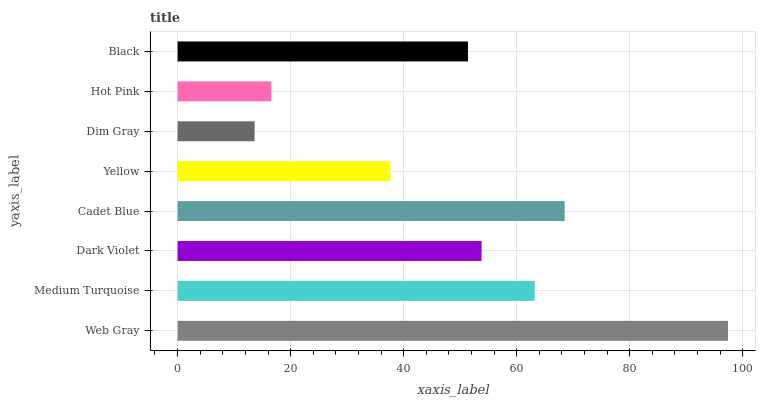Is Dim Gray the minimum?
Answer yes or no. Yes. Is Web Gray the maximum?
Answer yes or no. Yes. Is Medium Turquoise the minimum?
Answer yes or no. No. Is Medium Turquoise the maximum?
Answer yes or no. No. Is Web Gray greater than Medium Turquoise?
Answer yes or no. Yes. Is Medium Turquoise less than Web Gray?
Answer yes or no. Yes. Is Medium Turquoise greater than Web Gray?
Answer yes or no. No. Is Web Gray less than Medium Turquoise?
Answer yes or no. No. Is Dark Violet the high median?
Answer yes or no. Yes. Is Black the low median?
Answer yes or no. Yes. Is Cadet Blue the high median?
Answer yes or no. No. Is Yellow the low median?
Answer yes or no. No. 